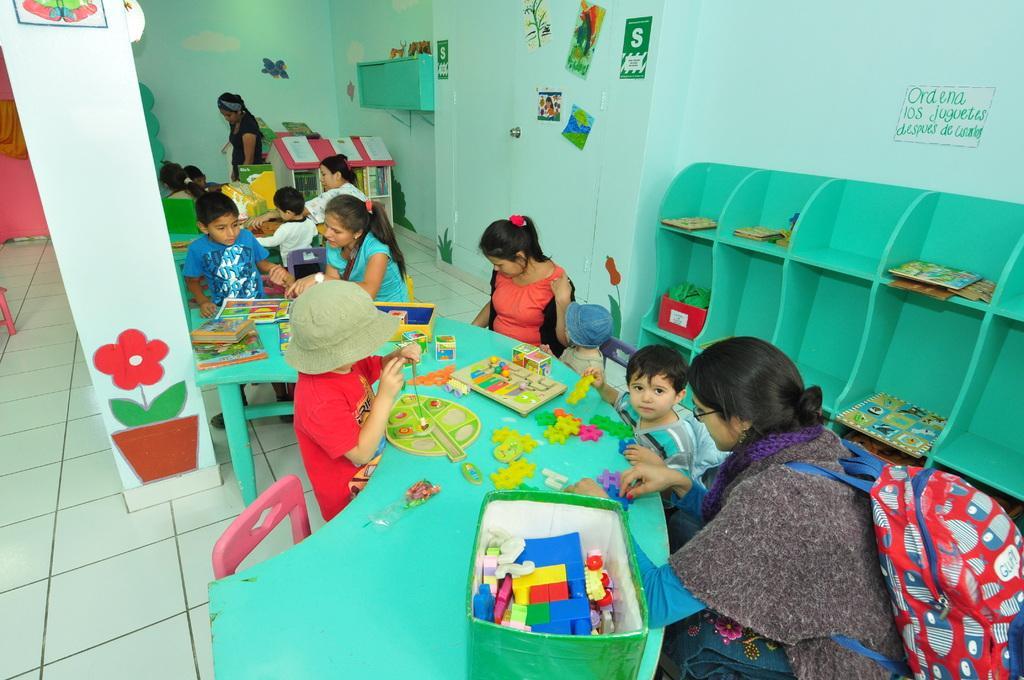Can you describe this image briefly? As we can see in the image there is a wall, few people here and there, chairs and tables. On table there are building boxes and posters. 